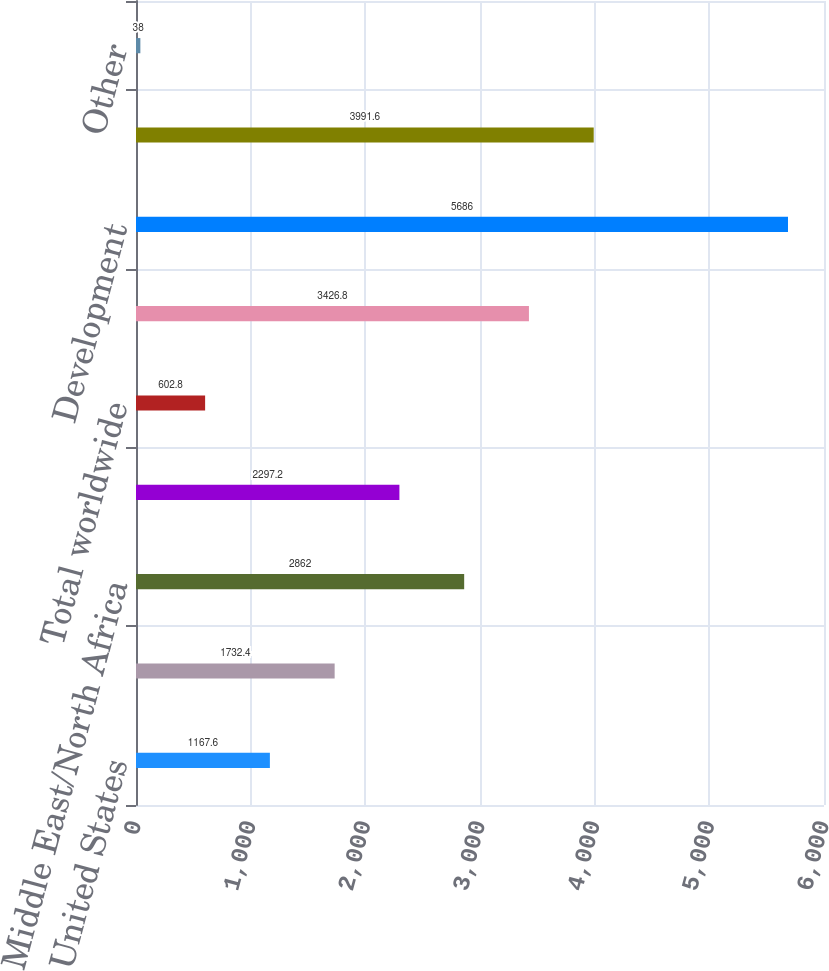<chart> <loc_0><loc_0><loc_500><loc_500><bar_chart><fcel>United States<fcel>Latin America (a)<fcel>Middle East/North Africa<fcel>Total worldwide (a)<fcel>Total worldwide<fcel>Expensed Exploration<fcel>Development<fcel>Exploration<fcel>Other<nl><fcel>1167.6<fcel>1732.4<fcel>2862<fcel>2297.2<fcel>602.8<fcel>3426.8<fcel>5686<fcel>3991.6<fcel>38<nl></chart> 